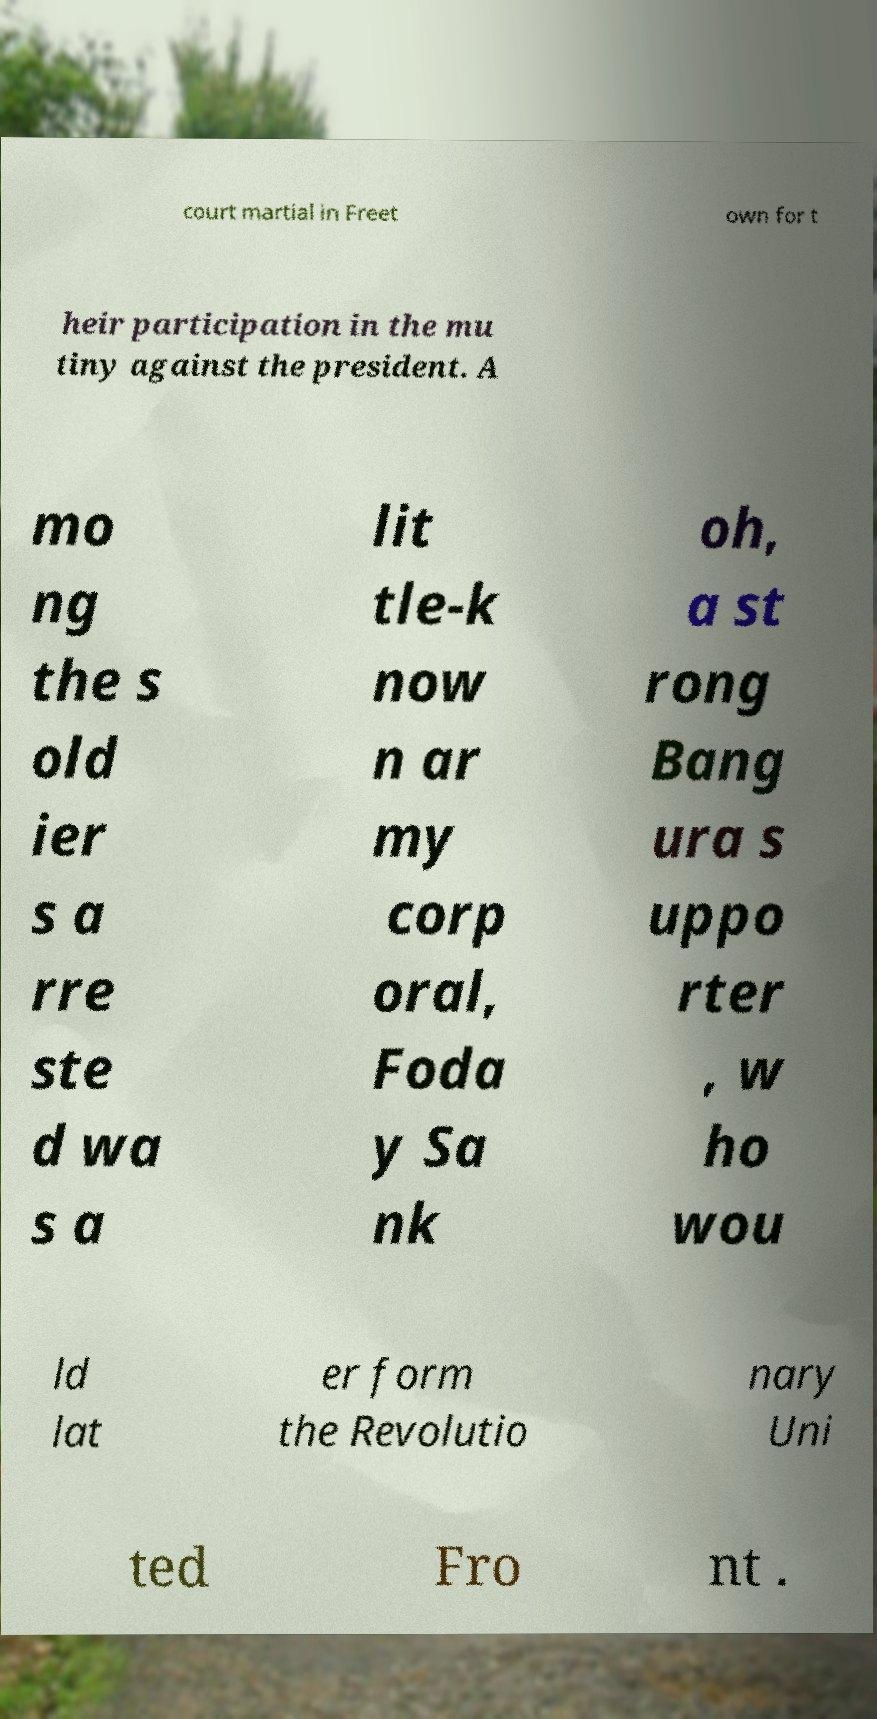What messages or text are displayed in this image? I need them in a readable, typed format. court martial in Freet own for t heir participation in the mu tiny against the president. A mo ng the s old ier s a rre ste d wa s a lit tle-k now n ar my corp oral, Foda y Sa nk oh, a st rong Bang ura s uppo rter , w ho wou ld lat er form the Revolutio nary Uni ted Fro nt . 